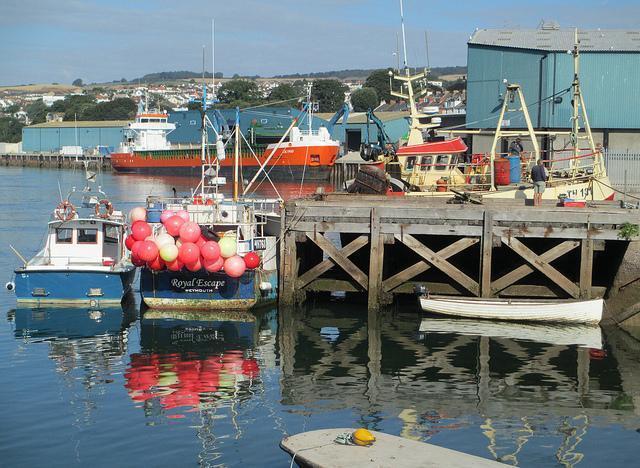How many boats are there?
Give a very brief answer. 4. How many boats can you see?
Give a very brief answer. 3. How many dogs are to the right of the person?
Give a very brief answer. 0. 